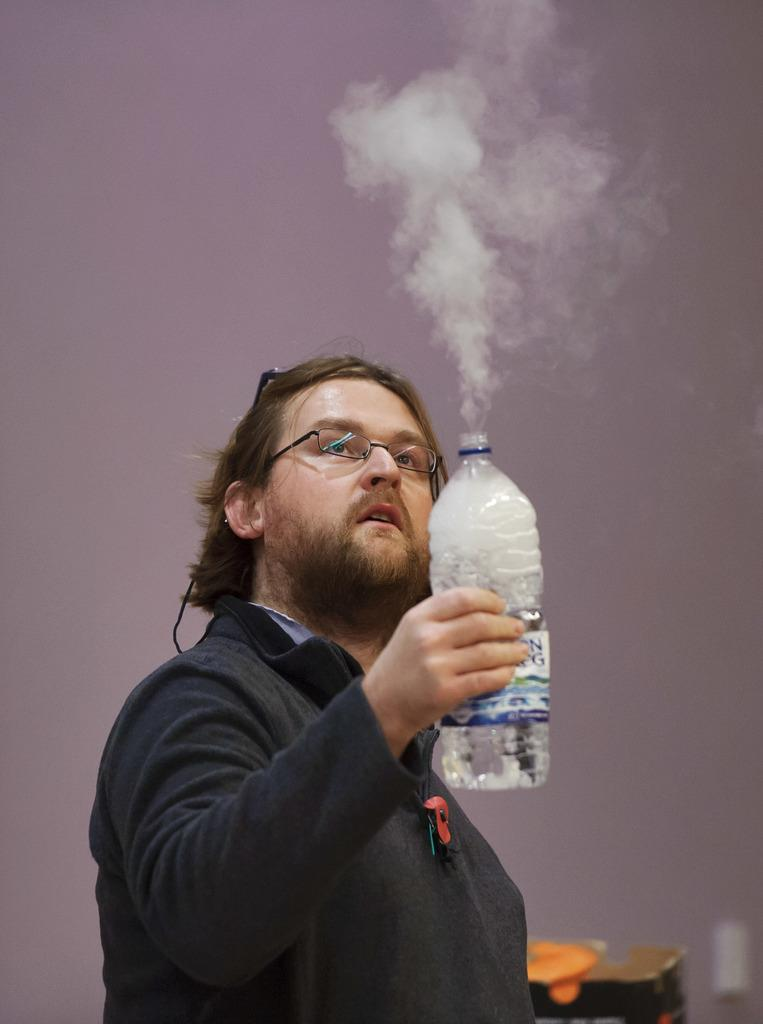Who is present in the image? There is a man in the image. What can be seen on the man's face? The man is wearing spectacles. What is the man holding in his hand? The man is holding a bottle in his hand. What can be seen in the background of the image? There is a wall and a table in the background of the image. What type of shoes is the man wearing in the image? The image does not show the man's shoes, so it cannot be determined from the image. 